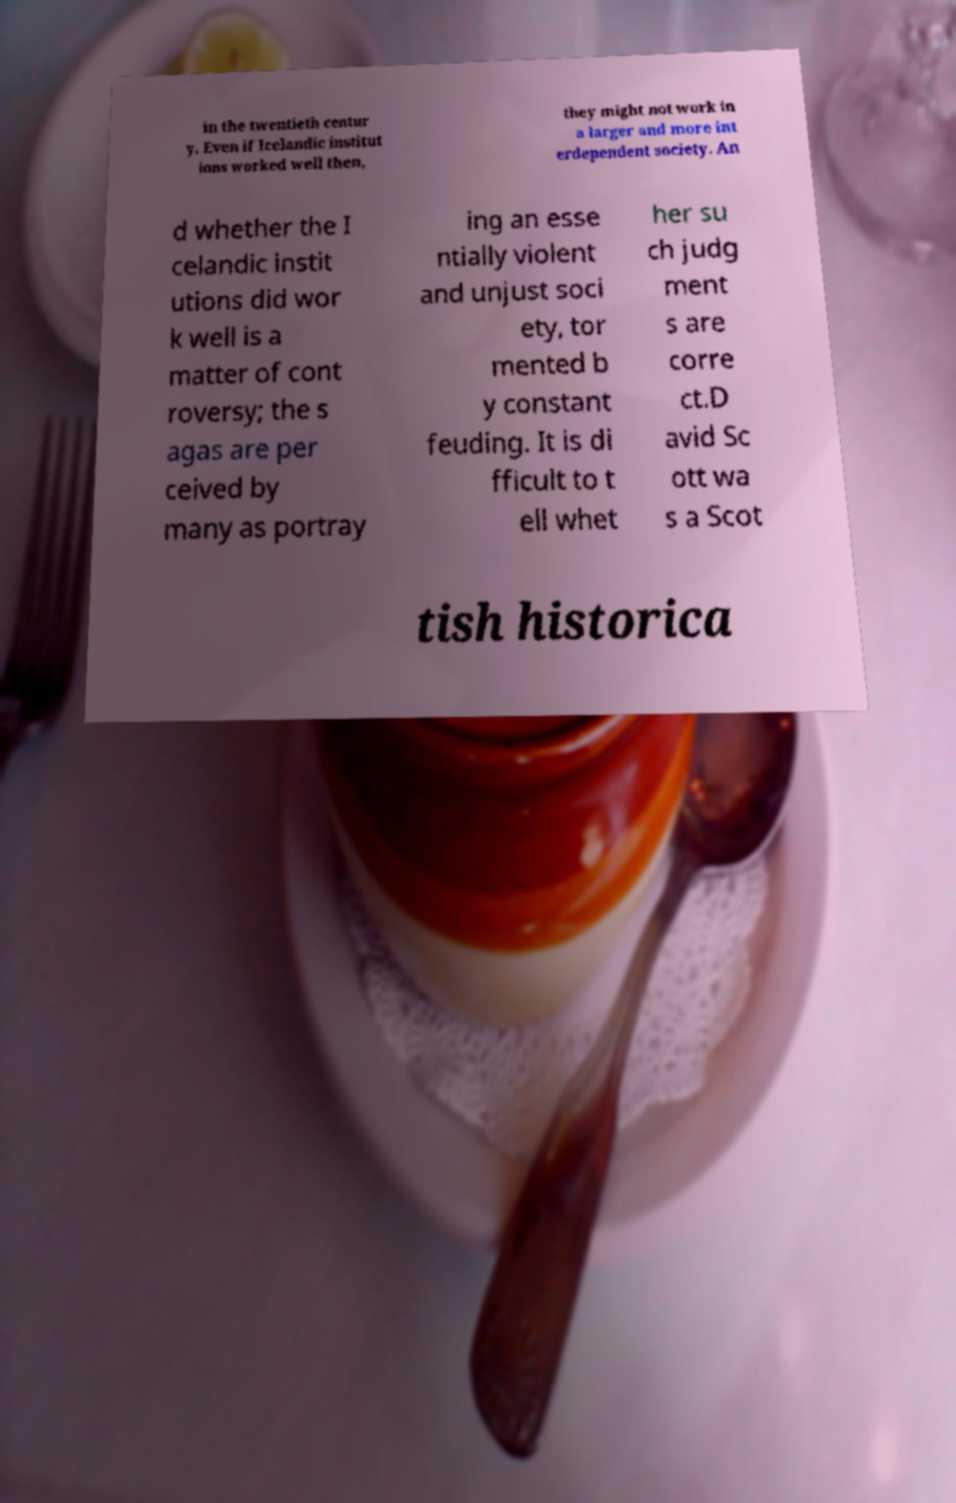Could you extract and type out the text from this image? in the twentieth centur y. Even if Icelandic institut ions worked well then, they might not work in a larger and more int erdependent society. An d whether the I celandic instit utions did wor k well is a matter of cont roversy; the s agas are per ceived by many as portray ing an esse ntially violent and unjust soci ety, tor mented b y constant feuding. It is di fficult to t ell whet her su ch judg ment s are corre ct.D avid Sc ott wa s a Scot tish historica 